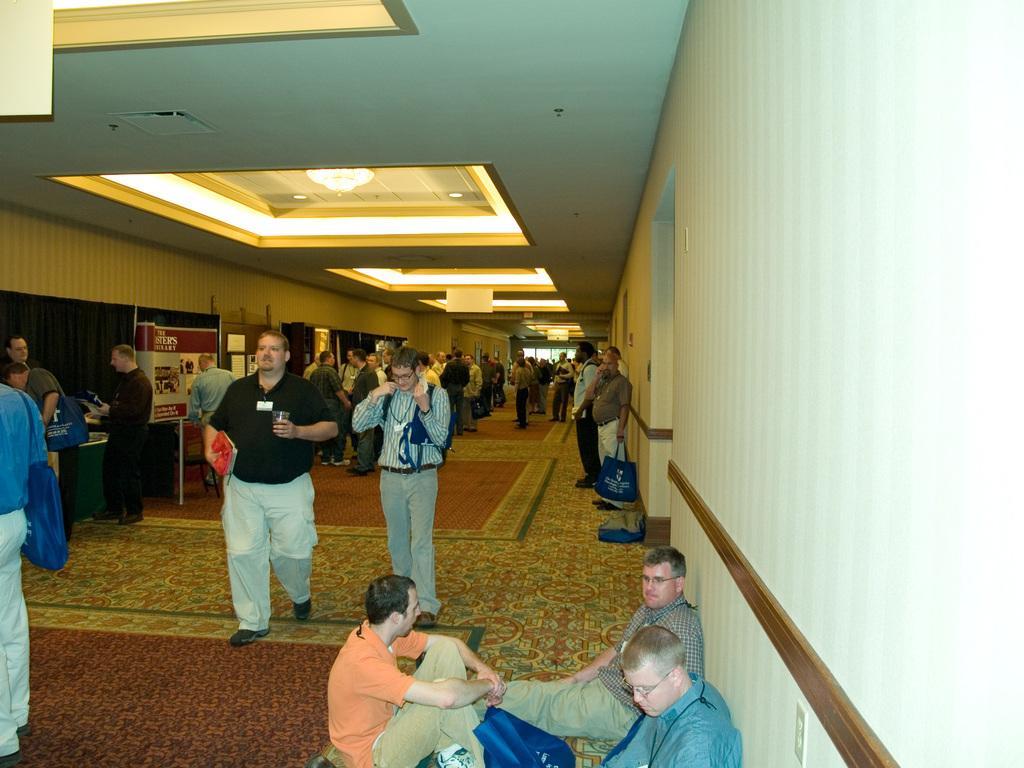Could you give a brief overview of what you see in this image? In this image I see number of people in which this man is holding red color thing in one hand and a glass in other hand and I see that these 3 men are sitting and I see the path and I see the wall and I see a board over here on which there is something written and I see the lights on the ceiling and I see that this man is holding a blue color bag. 